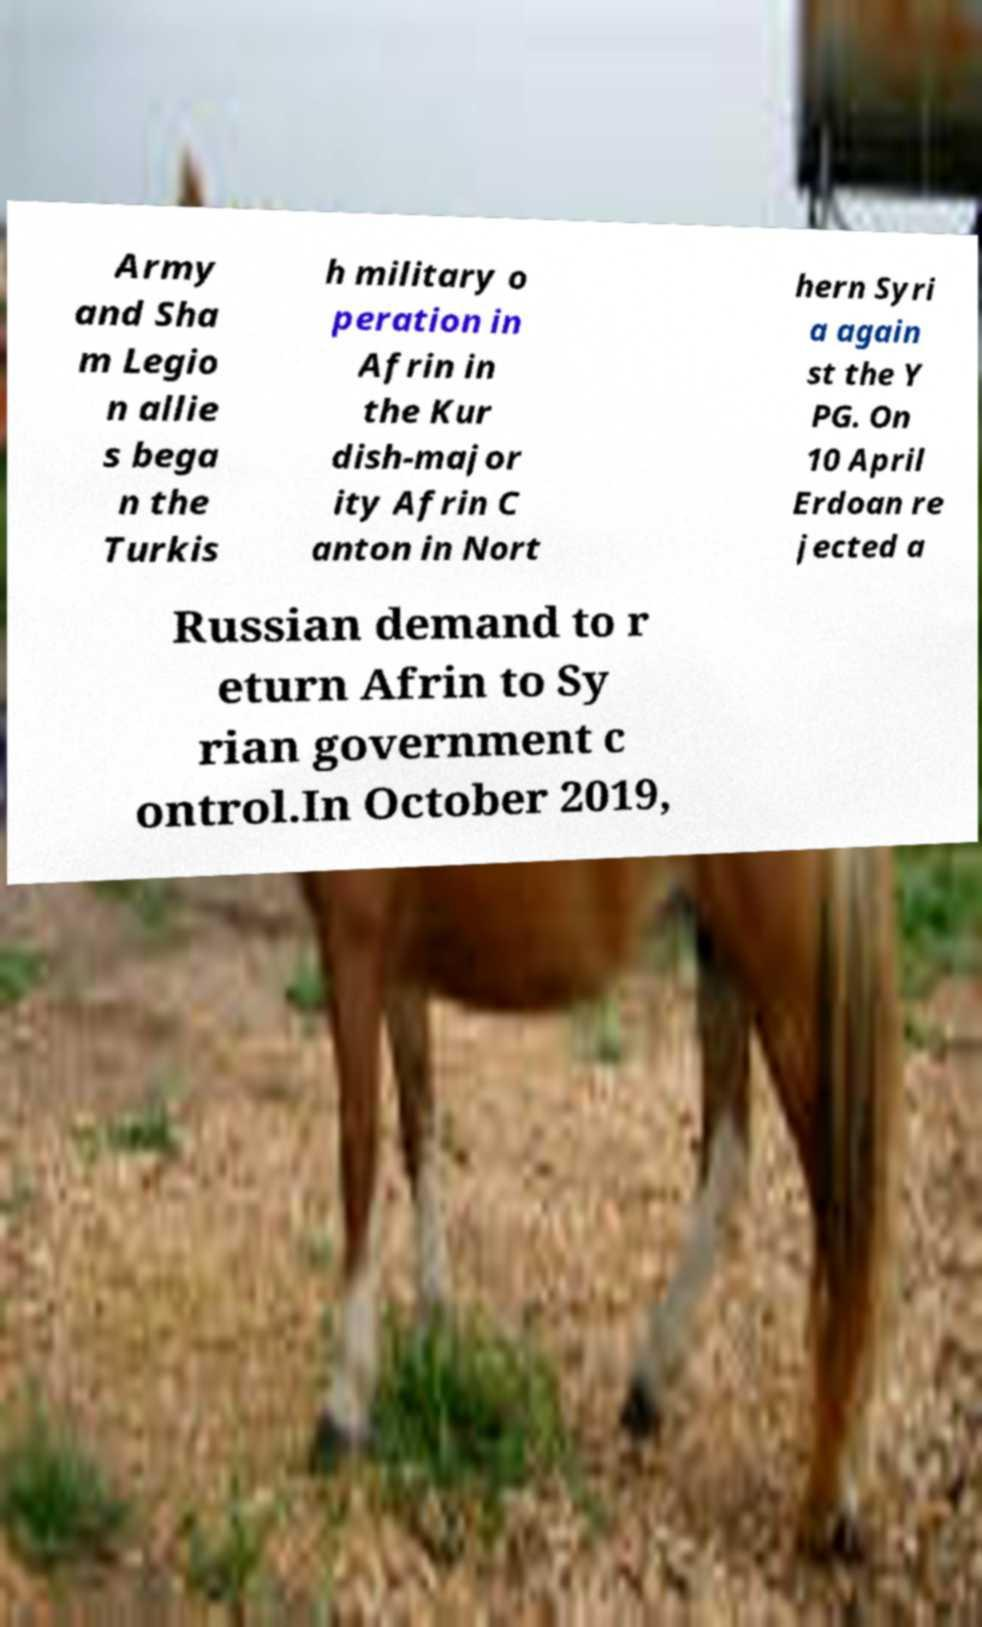Can you read and provide the text displayed in the image?This photo seems to have some interesting text. Can you extract and type it out for me? Army and Sha m Legio n allie s bega n the Turkis h military o peration in Afrin in the Kur dish-major ity Afrin C anton in Nort hern Syri a again st the Y PG. On 10 April Erdoan re jected a Russian demand to r eturn Afrin to Sy rian government c ontrol.In October 2019, 